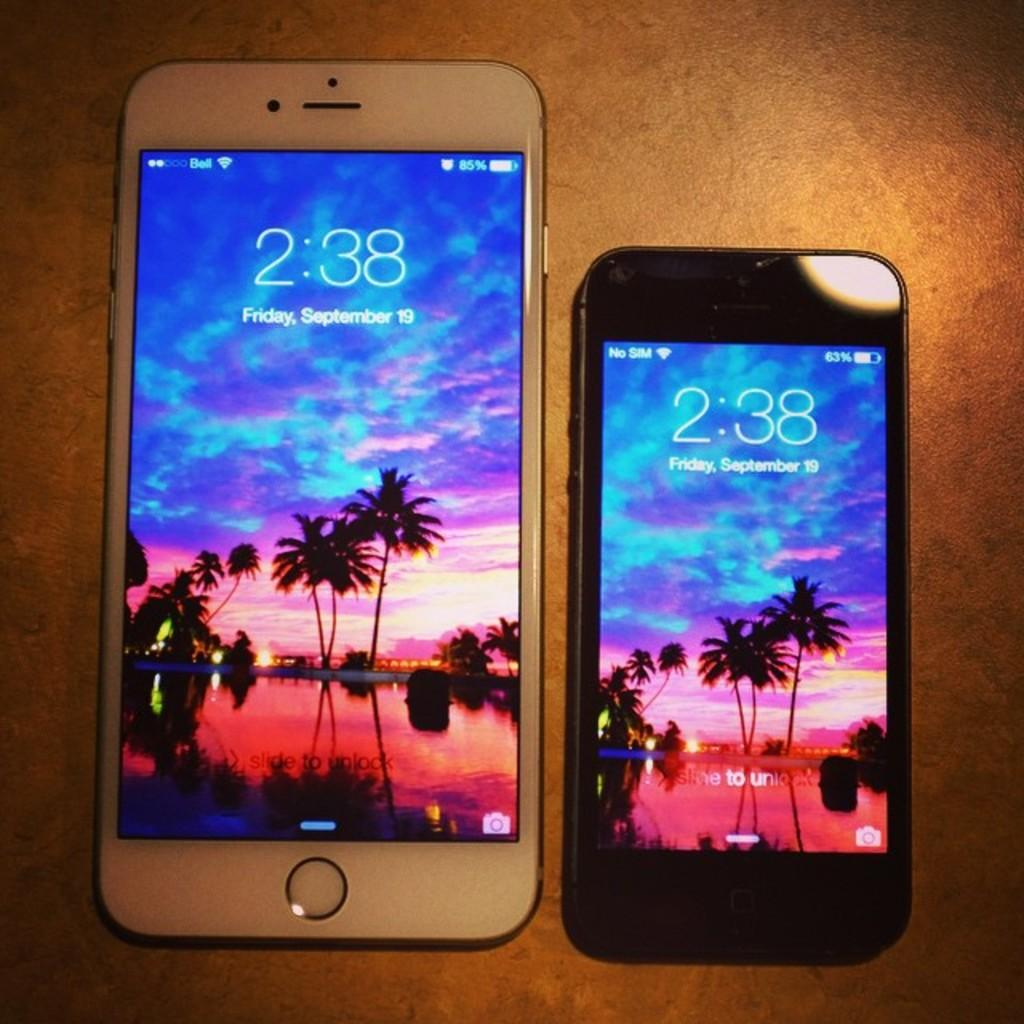<image>
Render a clear and concise summary of the photo. Two cell phones both display the date of Friday, September 19th. 